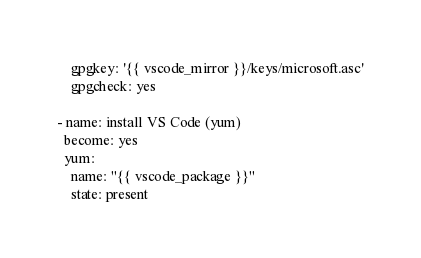Convert code to text. <code><loc_0><loc_0><loc_500><loc_500><_YAML_>    gpgkey: '{{ vscode_mirror }}/keys/microsoft.asc'
    gpgcheck: yes

- name: install VS Code (yum)
  become: yes
  yum:
    name: "{{ vscode_package }}"
    state: present
</code> 